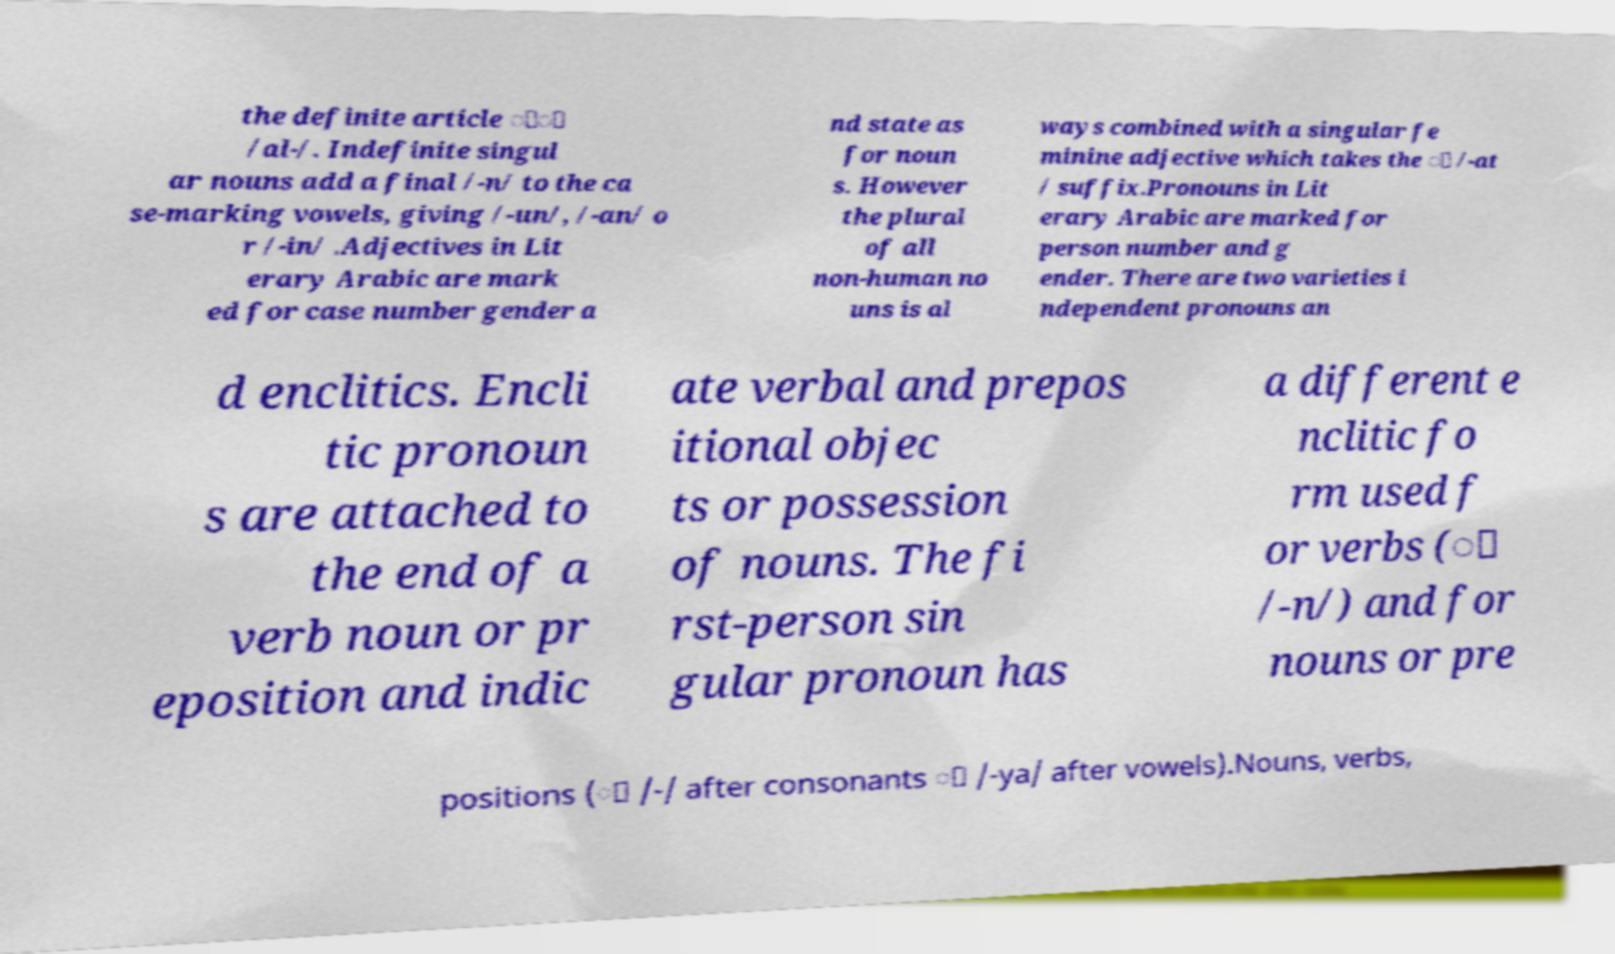Please read and relay the text visible in this image. What does it say? the definite article َْ /al-/. Indefinite singul ar nouns add a final /-n/ to the ca se-marking vowels, giving /-un/, /-an/ o r /-in/ .Adjectives in Lit erary Arabic are mark ed for case number gender a nd state as for noun s. However the plural of all non-human no uns is al ways combined with a singular fe minine adjective which takes the َ /-at / suffix.Pronouns in Lit erary Arabic are marked for person number and g ender. There are two varieties i ndependent pronouns an d enclitics. Encli tic pronoun s are attached to the end of a verb noun or pr eposition and indic ate verbal and prepos itional objec ts or possession of nouns. The fi rst-person sin gular pronoun has a different e nclitic fo rm used f or verbs (ِ /-n/) and for nouns or pre positions (ِ /-/ after consonants َ /-ya/ after vowels).Nouns, verbs, 